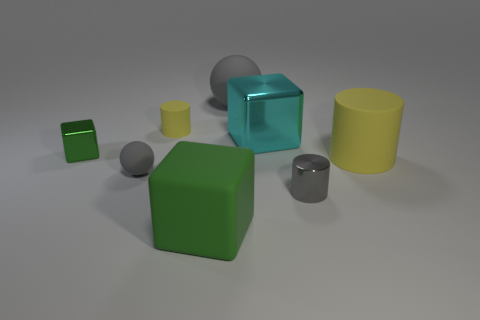Does the yellow rubber object behind the big cyan object have the same shape as the cyan metal thing?
Offer a terse response. No. What is the small gray sphere made of?
Provide a short and direct response. Rubber. What shape is the green rubber object that is the same size as the cyan shiny block?
Your response must be concise. Cube. Are there any other cubes of the same color as the matte cube?
Keep it short and to the point. Yes. Do the big sphere and the cylinder that is in front of the small gray matte object have the same color?
Your response must be concise. Yes. There is a thing that is right of the small cylinder that is in front of the cyan block; what is its color?
Provide a short and direct response. Yellow. Is there a cyan thing that is in front of the yellow matte cylinder that is on the right side of the tiny matte object that is behind the large metal object?
Provide a short and direct response. No. There is a small thing that is made of the same material as the tiny green cube; what is its color?
Keep it short and to the point. Gray. How many gray things are made of the same material as the small sphere?
Give a very brief answer. 1. Is the small green thing made of the same material as the large cube behind the small green thing?
Provide a succinct answer. Yes. 